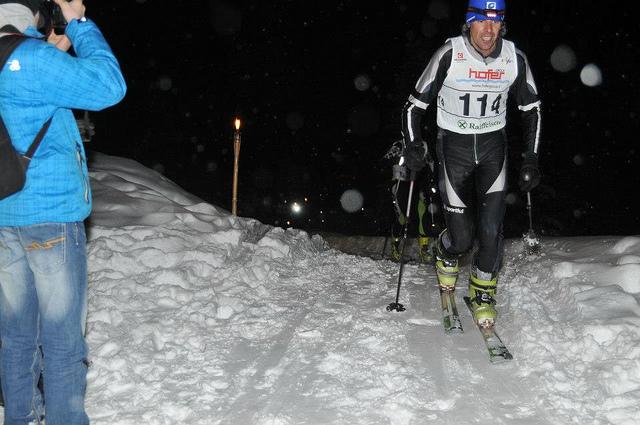Is it night time?
Quick response, please. Yes. What number is this cross country skier?
Quick response, please. 114. Is the man's hat the same color of the snow?
Quick response, please. No. How many people with blue shirts?
Keep it brief. 1. What is on the ground?
Quick response, please. Snow. 